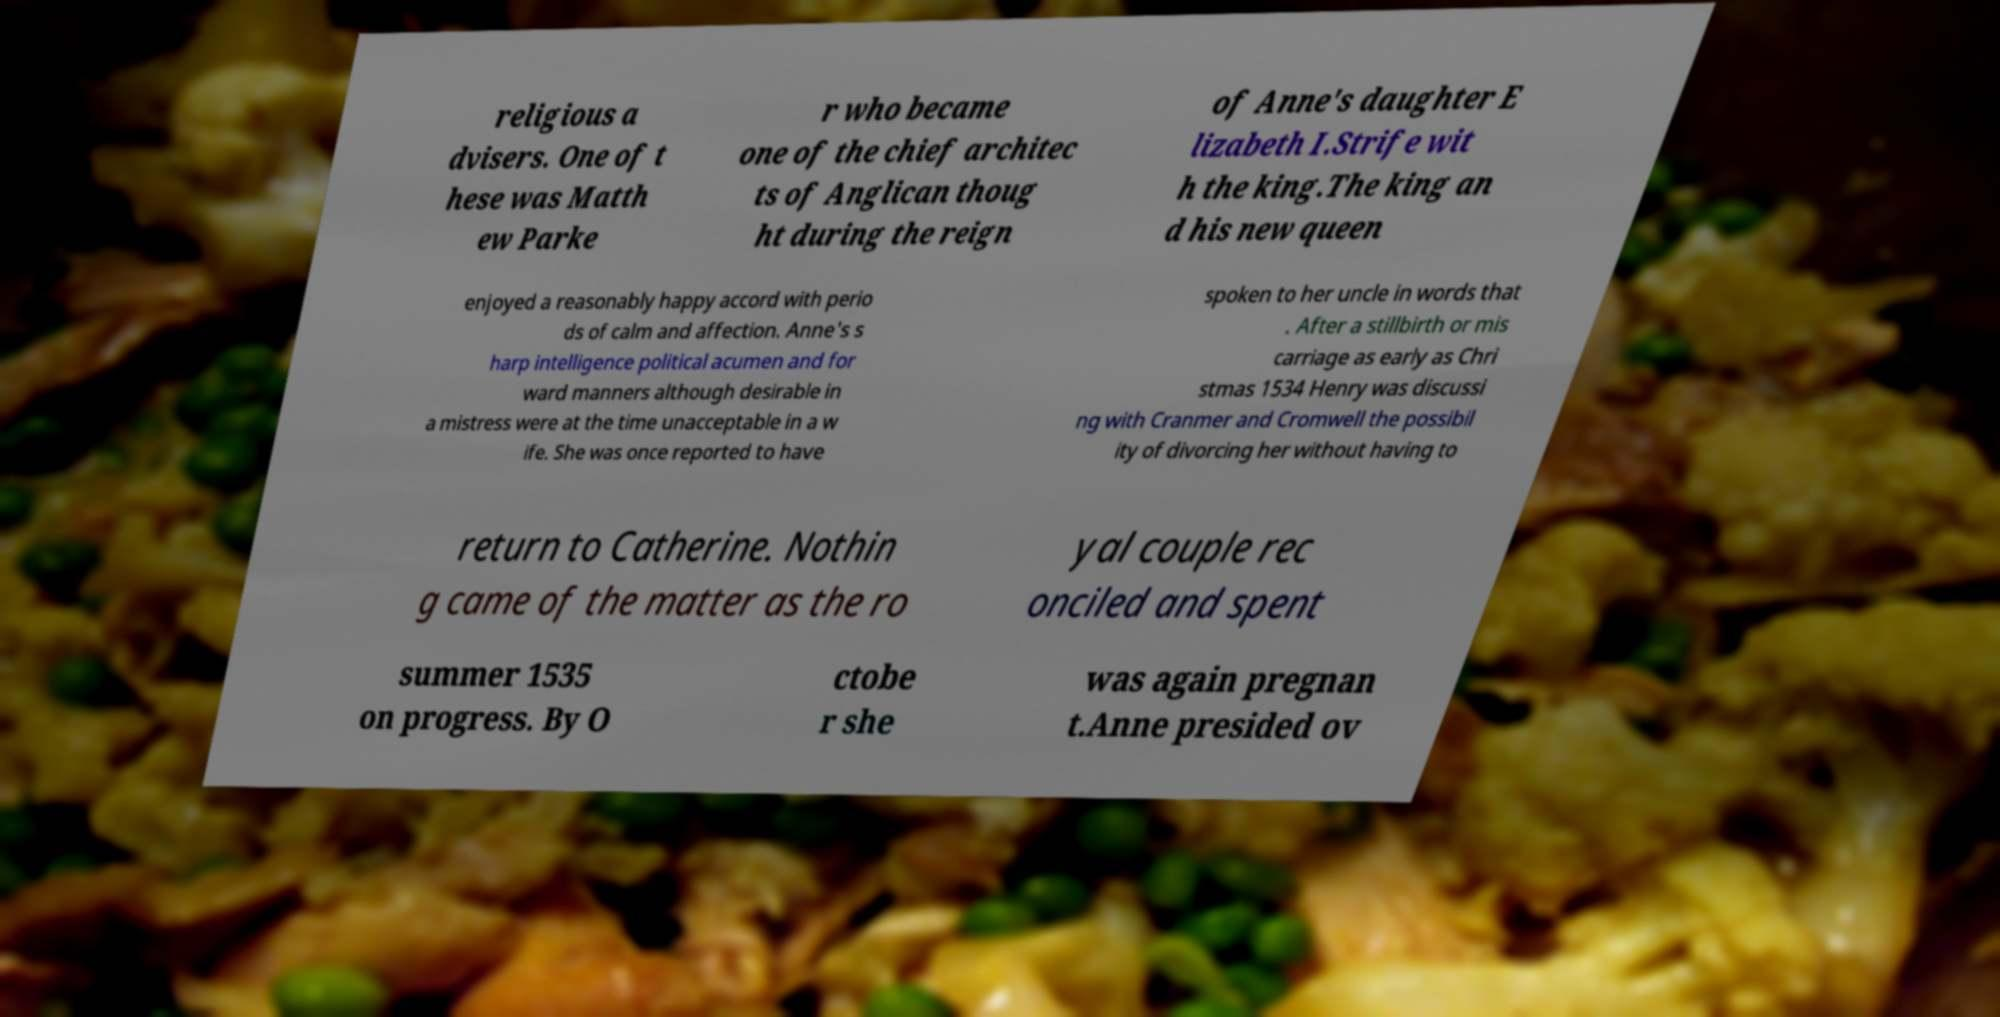Please read and relay the text visible in this image. What does it say? religious a dvisers. One of t hese was Matth ew Parke r who became one of the chief architec ts of Anglican thoug ht during the reign of Anne's daughter E lizabeth I.Strife wit h the king.The king an d his new queen enjoyed a reasonably happy accord with perio ds of calm and affection. Anne's s harp intelligence political acumen and for ward manners although desirable in a mistress were at the time unacceptable in a w ife. She was once reported to have spoken to her uncle in words that . After a stillbirth or mis carriage as early as Chri stmas 1534 Henry was discussi ng with Cranmer and Cromwell the possibil ity of divorcing her without having to return to Catherine. Nothin g came of the matter as the ro yal couple rec onciled and spent summer 1535 on progress. By O ctobe r she was again pregnan t.Anne presided ov 